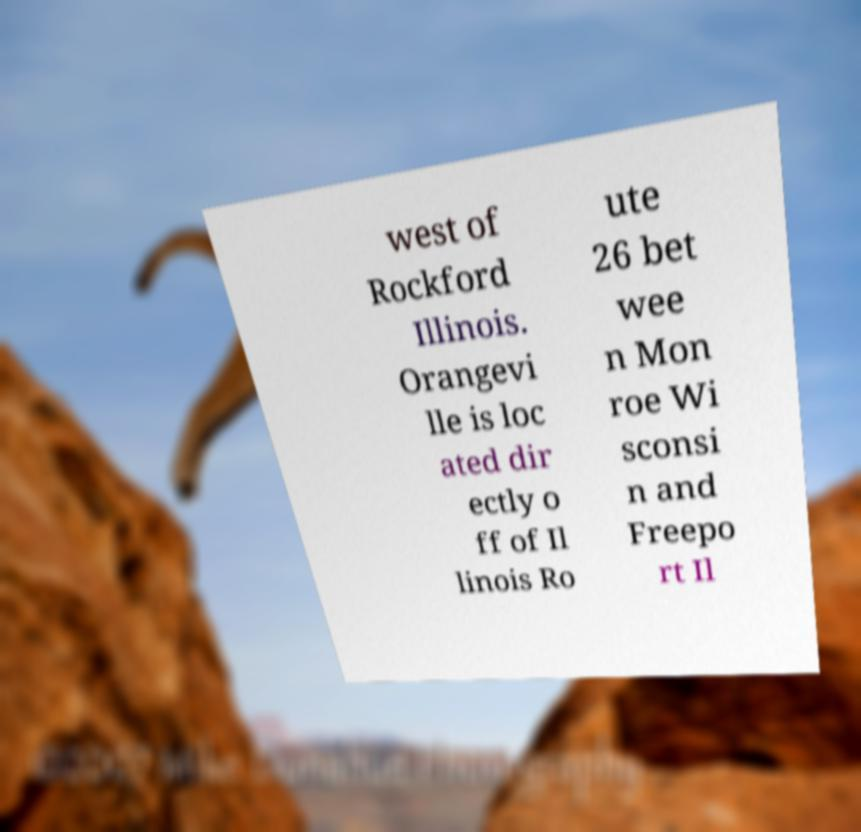Can you read and provide the text displayed in the image?This photo seems to have some interesting text. Can you extract and type it out for me? west of Rockford Illinois. Orangevi lle is loc ated dir ectly o ff of Il linois Ro ute 26 bet wee n Mon roe Wi sconsi n and Freepo rt Il 